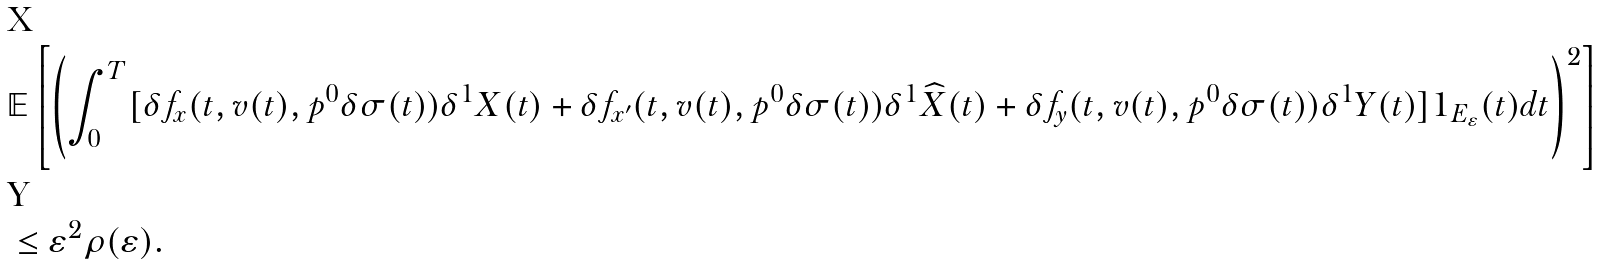<formula> <loc_0><loc_0><loc_500><loc_500>& \mathbb { E } \left [ \left ( \int _ { 0 } ^ { T } [ \delta f _ { x } ( t , v ( t ) , p ^ { 0 } \delta \sigma ( t ) ) \delta ^ { 1 } X ( t ) + \delta f _ { x ^ { \prime } } ( t , v ( t ) , p ^ { 0 } \delta \sigma ( t ) ) \delta ^ { 1 } \widehat { X } ( t ) + \delta f _ { y } ( t , v ( t ) , p ^ { 0 } \delta \sigma ( t ) ) \delta ^ { 1 } Y ( t ) ] 1 _ { E _ { \varepsilon } } ( t ) d t \right ) ^ { 2 } \right ] \\ & \leq \varepsilon ^ { 2 } \rho ( \varepsilon ) .</formula> 